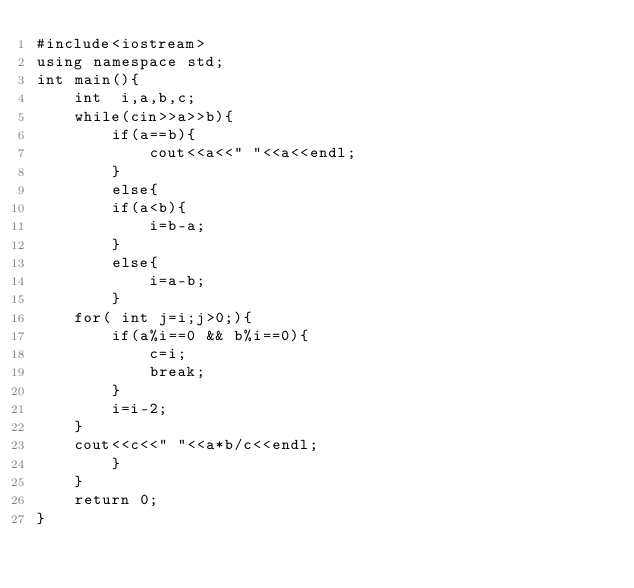<code> <loc_0><loc_0><loc_500><loc_500><_C++_>#include<iostream>
using namespace std;
int main(){
    int  i,a,b,c;
    while(cin>>a>>b){
        if(a==b){
            cout<<a<<" "<<a<<endl;
        }
        else{
        if(a<b){
            i=b-a;
        }
        else{
            i=a-b;
        }
    for( int j=i;j>0;){
        if(a%i==0 && b%i==0){
            c=i;
            break;
        }
        i=i-2;
    }
    cout<<c<<" "<<a*b/c<<endl;
        }
    }
    return 0;
}</code> 